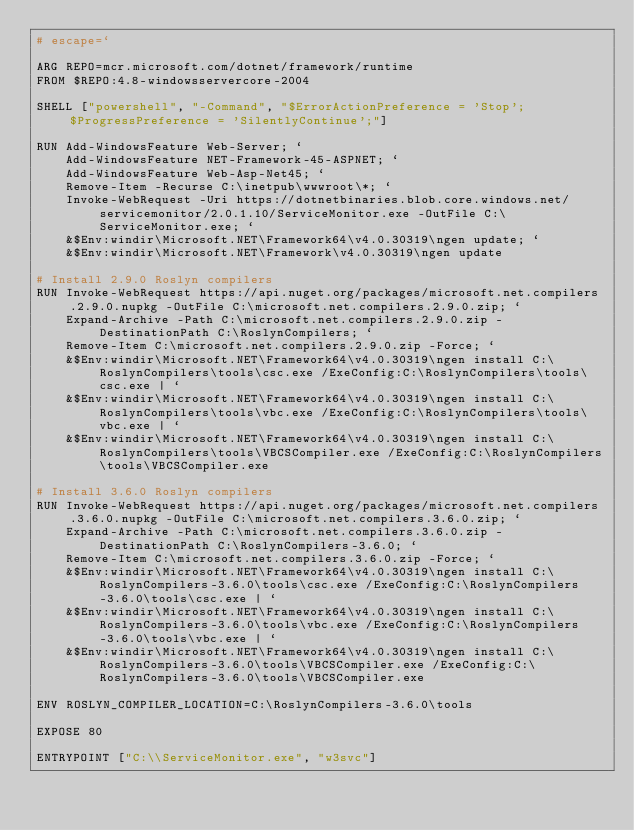<code> <loc_0><loc_0><loc_500><loc_500><_Dockerfile_># escape=`

ARG REPO=mcr.microsoft.com/dotnet/framework/runtime
FROM $REPO:4.8-windowsservercore-2004

SHELL ["powershell", "-Command", "$ErrorActionPreference = 'Stop'; $ProgressPreference = 'SilentlyContinue';"]

RUN Add-WindowsFeature Web-Server; `
    Add-WindowsFeature NET-Framework-45-ASPNET; `
    Add-WindowsFeature Web-Asp-Net45; `
    Remove-Item -Recurse C:\inetpub\wwwroot\*; `
    Invoke-WebRequest -Uri https://dotnetbinaries.blob.core.windows.net/servicemonitor/2.0.1.10/ServiceMonitor.exe -OutFile C:\ServiceMonitor.exe; `
    &$Env:windir\Microsoft.NET\Framework64\v4.0.30319\ngen update; `
    &$Env:windir\Microsoft.NET\Framework\v4.0.30319\ngen update

# Install 2.9.0 Roslyn compilers
RUN Invoke-WebRequest https://api.nuget.org/packages/microsoft.net.compilers.2.9.0.nupkg -OutFile C:\microsoft.net.compilers.2.9.0.zip; `
    Expand-Archive -Path C:\microsoft.net.compilers.2.9.0.zip -DestinationPath C:\RoslynCompilers; `
    Remove-Item C:\microsoft.net.compilers.2.9.0.zip -Force; `
    &$Env:windir\Microsoft.NET\Framework64\v4.0.30319\ngen install C:\RoslynCompilers\tools\csc.exe /ExeConfig:C:\RoslynCompilers\tools\csc.exe | `
    &$Env:windir\Microsoft.NET\Framework64\v4.0.30319\ngen install C:\RoslynCompilers\tools\vbc.exe /ExeConfig:C:\RoslynCompilers\tools\vbc.exe | `
    &$Env:windir\Microsoft.NET\Framework64\v4.0.30319\ngen install C:\RoslynCompilers\tools\VBCSCompiler.exe /ExeConfig:C:\RoslynCompilers\tools\VBCSCompiler.exe

# Install 3.6.0 Roslyn compilers
RUN Invoke-WebRequest https://api.nuget.org/packages/microsoft.net.compilers.3.6.0.nupkg -OutFile C:\microsoft.net.compilers.3.6.0.zip; `
    Expand-Archive -Path C:\microsoft.net.compilers.3.6.0.zip -DestinationPath C:\RoslynCompilers-3.6.0; `
    Remove-Item C:\microsoft.net.compilers.3.6.0.zip -Force; `
    &$Env:windir\Microsoft.NET\Framework64\v4.0.30319\ngen install C:\RoslynCompilers-3.6.0\tools\csc.exe /ExeConfig:C:\RoslynCompilers-3.6.0\tools\csc.exe | `
    &$Env:windir\Microsoft.NET\Framework64\v4.0.30319\ngen install C:\RoslynCompilers-3.6.0\tools\vbc.exe /ExeConfig:C:\RoslynCompilers-3.6.0\tools\vbc.exe | `
    &$Env:windir\Microsoft.NET\Framework64\v4.0.30319\ngen install C:\RoslynCompilers-3.6.0\tools\VBCSCompiler.exe /ExeConfig:C:\RoslynCompilers-3.6.0\tools\VBCSCompiler.exe

ENV ROSLYN_COMPILER_LOCATION=C:\RoslynCompilers-3.6.0\tools

EXPOSE 80

ENTRYPOINT ["C:\\ServiceMonitor.exe", "w3svc"]
</code> 